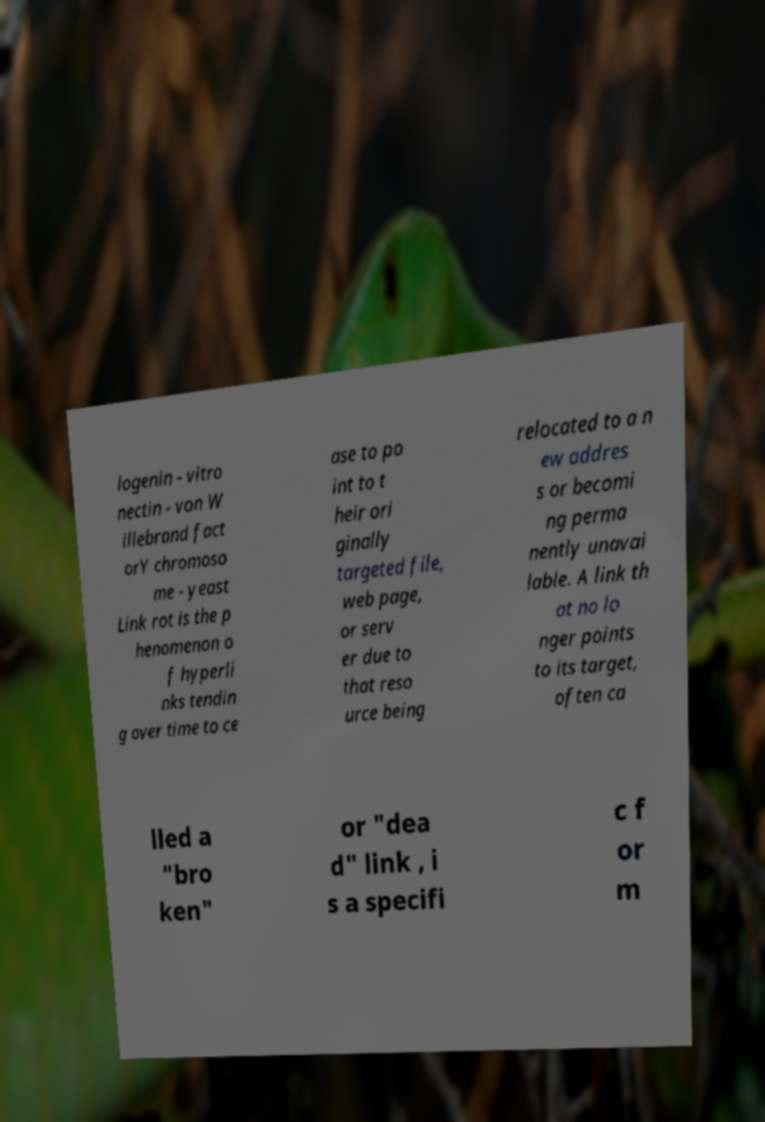What messages or text are displayed in this image? I need them in a readable, typed format. logenin - vitro nectin - von W illebrand fact orY chromoso me - yeast Link rot is the p henomenon o f hyperli nks tendin g over time to ce ase to po int to t heir ori ginally targeted file, web page, or serv er due to that reso urce being relocated to a n ew addres s or becomi ng perma nently unavai lable. A link th at no lo nger points to its target, often ca lled a "bro ken" or "dea d" link , i s a specifi c f or m 